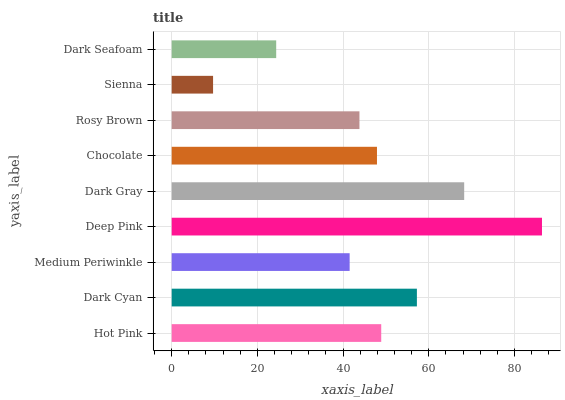Is Sienna the minimum?
Answer yes or no. Yes. Is Deep Pink the maximum?
Answer yes or no. Yes. Is Dark Cyan the minimum?
Answer yes or no. No. Is Dark Cyan the maximum?
Answer yes or no. No. Is Dark Cyan greater than Hot Pink?
Answer yes or no. Yes. Is Hot Pink less than Dark Cyan?
Answer yes or no. Yes. Is Hot Pink greater than Dark Cyan?
Answer yes or no. No. Is Dark Cyan less than Hot Pink?
Answer yes or no. No. Is Chocolate the high median?
Answer yes or no. Yes. Is Chocolate the low median?
Answer yes or no. Yes. Is Medium Periwinkle the high median?
Answer yes or no. No. Is Dark Seafoam the low median?
Answer yes or no. No. 